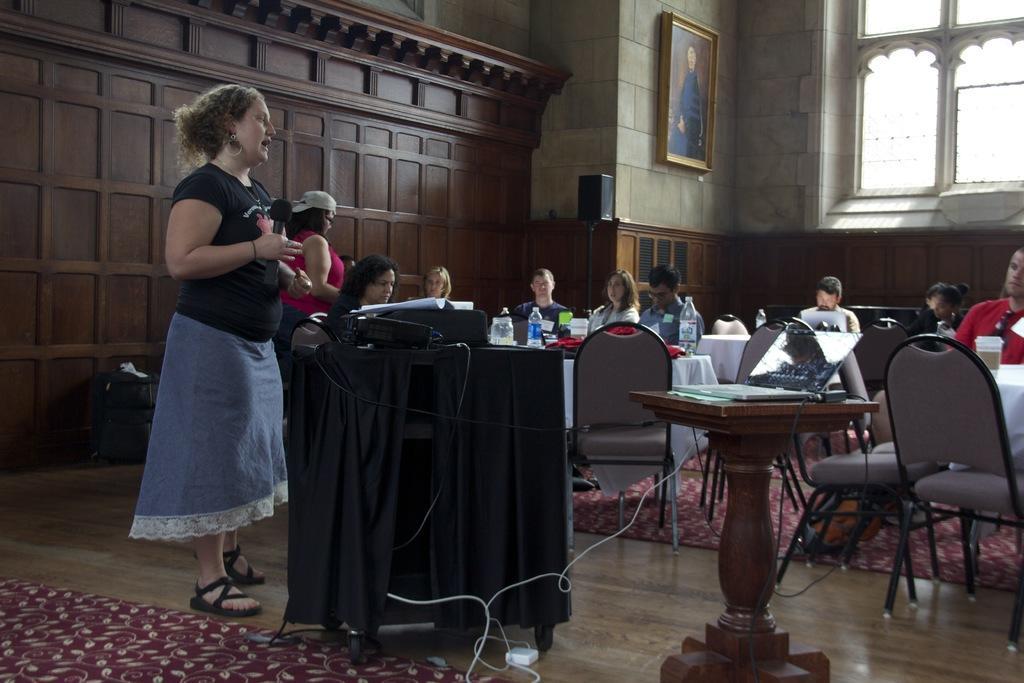Could you give a brief overview of what you see in this image? In this picture there is a woman standing holding a mic in her hand. There are some people sitting here in the chairs in front of their tables. In the background there is a photo frame attached to the wall and there is a speaker here. We can observe some Windows too. 